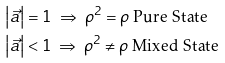<formula> <loc_0><loc_0><loc_500><loc_500>\left | { \vec { a } } \right | & = 1 { \text { } } \Rightarrow { \text { } } { \rho ^ { 2 } } = \rho { \text {  Pure State} } \\ \left | { \vec { a } } \right | & < 1 { \text { } } \Rightarrow { \text {  } } { \rho ^ { 2 } } \ne \rho { \text {  Mixed State} }</formula> 